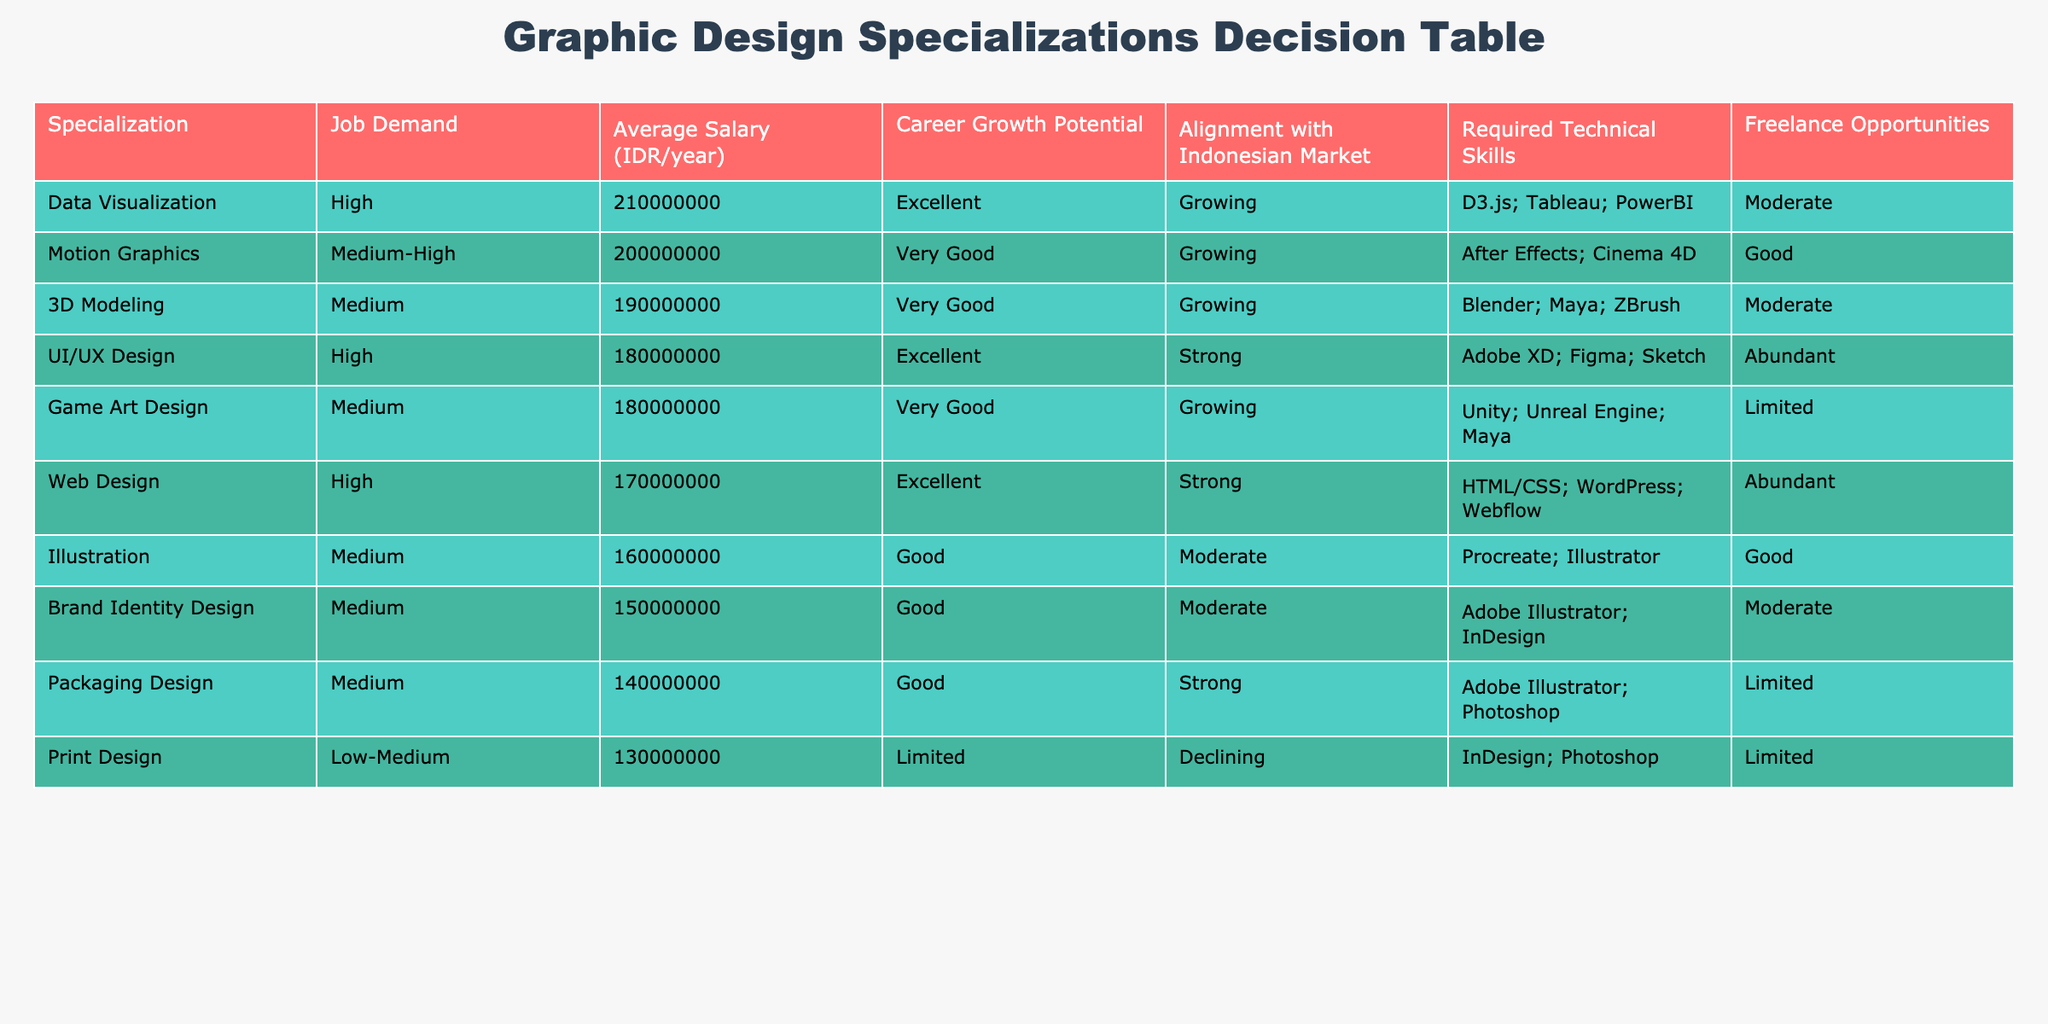What is the highest average salary among the specializations listed? The average salary for each specialization is shown in the table, with Data Visualization having the highest average salary at 210,000,000 IDR per year.
Answer: 210,000,000 IDR/year Which specialization has the lowest job demand? By scanning the table, Print Design is indicated to have low-medium job demand, while all other specializations show medium to high demand.
Answer: Print Design How many specializations have excellent career growth potential? The table lists three specializations with excellent career growth potential: UI/UX Design, Web Design, and Data Visualization. Counting these, there are three.
Answer: 3 Is there a specialization that offers abundant freelance opportunities and has high job demand? By examining the table, both UI/UX Design and Web Design fall into this category, as they show high job demand and are marked as having abundant freelance opportunities.
Answer: Yes What is the average salary difference between Motion Graphics and Brand Identity Design? The average salary for Motion Graphics is 200,000,000 IDR/year and for Brand Identity Design is 150,000,000 IDR/year. The difference is calculated as 200,000,000 - 150,000,000 = 50,000,000 IDR/year.
Answer: 50,000,000 IDR/year Based on the table, would you say that most specializations align well with the Indonesian market? By reviewing the 'Alignment with Indonesian Market' column, it's clear that the majority of specializations indicate a strong or moderate alignment. Therefore, the statement is true.
Answer: Yes Which specialization requires the most technical skills as seen in the table? By assessing the 'Required Technical Skills' column, it appears that Data Visualization requires a range of advanced skills like D3.js, Tableau, and PowerBI, indicating it has the most sophisticated requirements.
Answer: Data Visualization How many specializations are growing in the market according to the table? Upon reviewing the 'Career Growth Potential' column, the specializations that are marked as growing are Motion Graphics, 3D Modeling, Data Visualization, and Game Art Design. This results in four specializations showing growth.
Answer: 4 